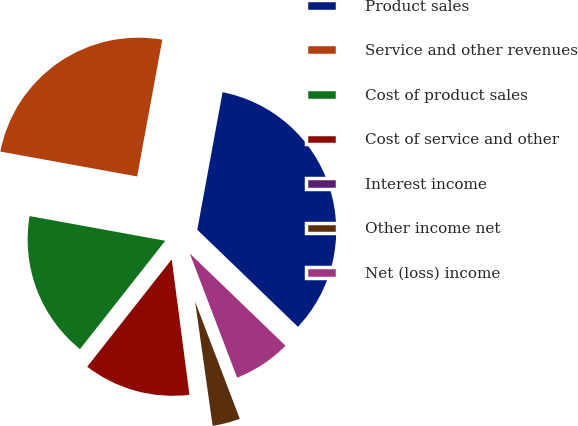Convert chart to OTSL. <chart><loc_0><loc_0><loc_500><loc_500><pie_chart><fcel>Product sales<fcel>Service and other revenues<fcel>Cost of product sales<fcel>Cost of service and other<fcel>Interest income<fcel>Other income net<fcel>Net (loss) income<nl><fcel>34.31%<fcel>25.03%<fcel>17.25%<fcel>12.68%<fcel>0.16%<fcel>3.57%<fcel>6.99%<nl></chart> 